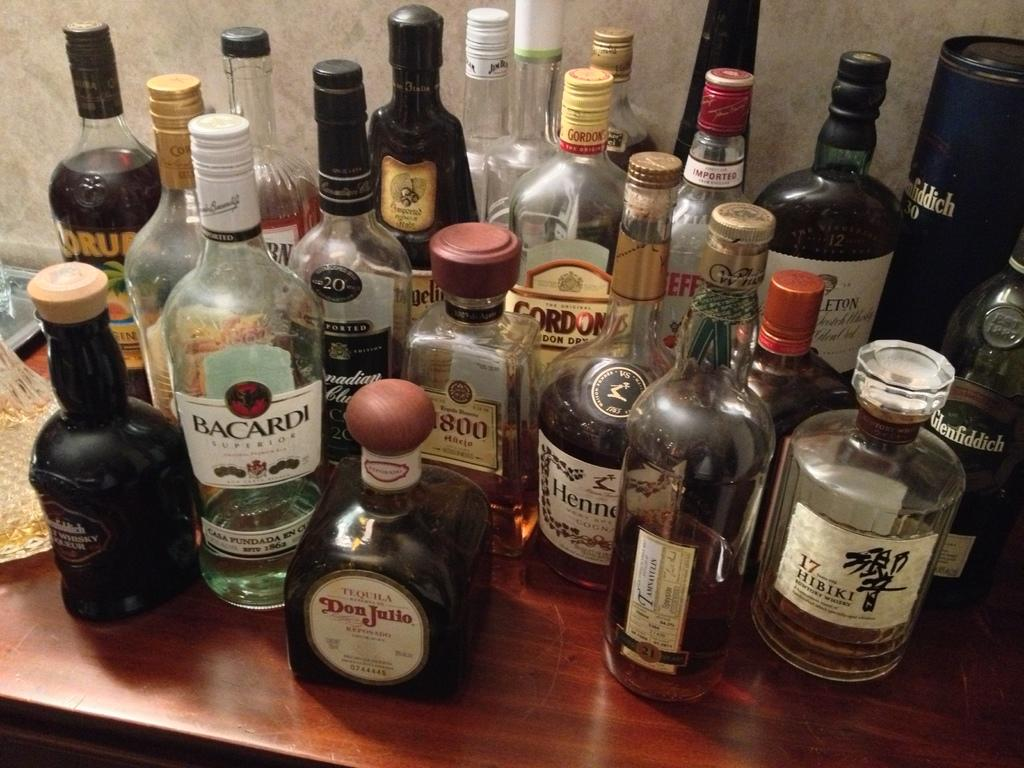<image>
Summarize the visual content of the image. Bottles of alcohol on a table including a Don Julio. 